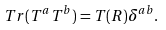<formula> <loc_0><loc_0><loc_500><loc_500>T r ( T ^ { a } T ^ { b } ) = T ( R ) \delta ^ { a b } .</formula> 